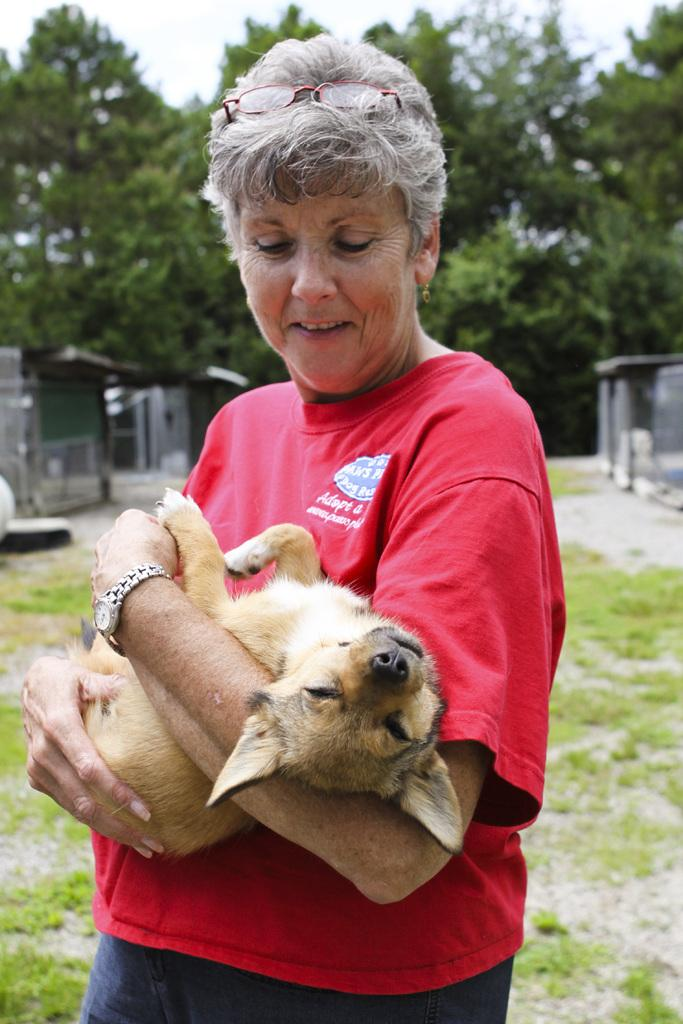Who is the main subject in the image? There is a woman in the image. What is the woman doing in the image? The woman is holding a dog with her hands. What can be seen in the background of the image? There are trees in the background of the image. What is visible at the top of the image? The sky is visible at the top of the image. How many dogs are present in the image? There is only one dog visible in the image, as the woman is holding it with her hands. 